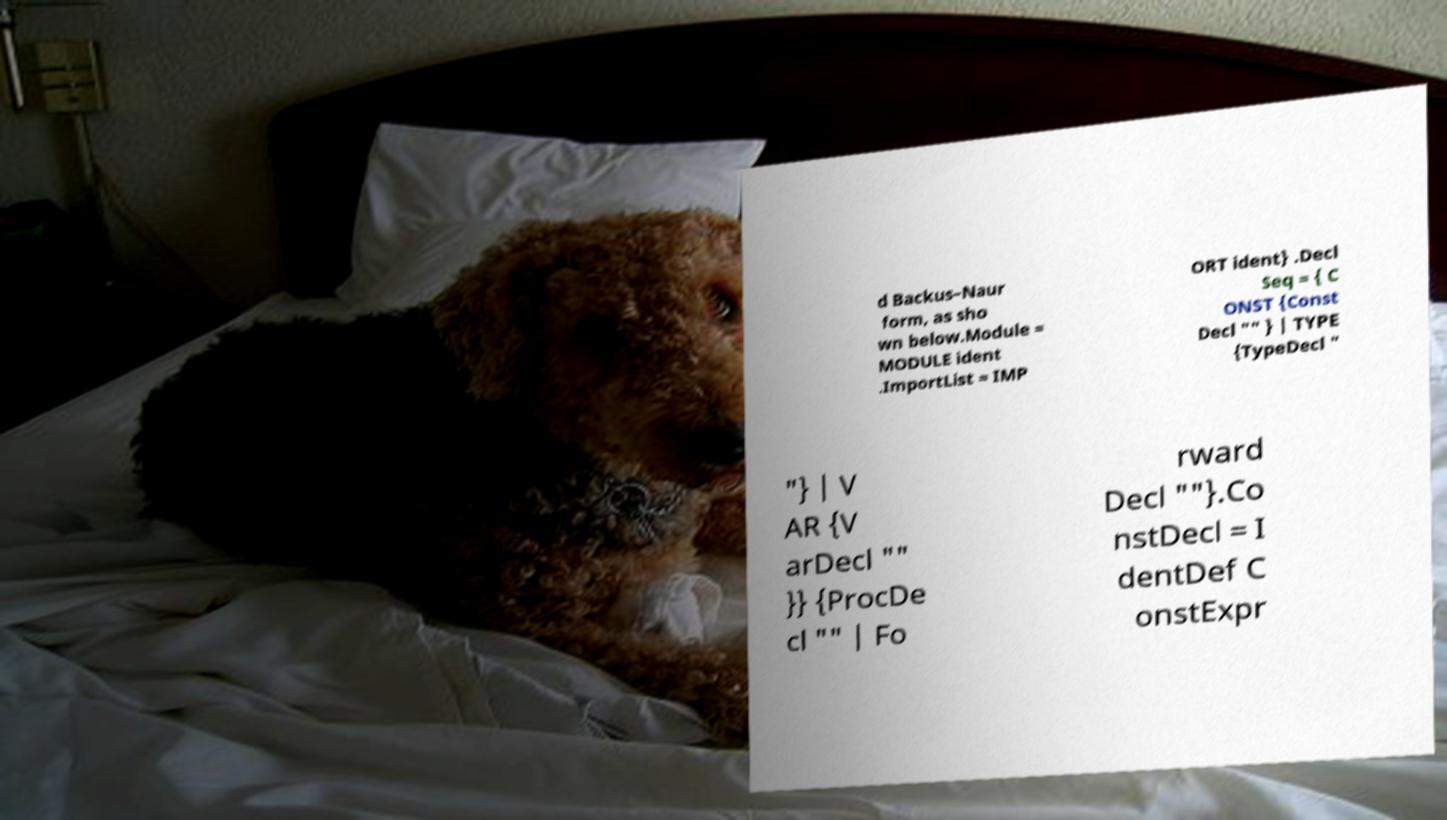I need the written content from this picture converted into text. Can you do that? d Backus–Naur form, as sho wn below.Module = MODULE ident .ImportList = IMP ORT ident} .Decl Seq = { C ONST {Const Decl "" } | TYPE {TypeDecl " "} | V AR {V arDecl "" }} {ProcDe cl "" | Fo rward Decl ""}.Co nstDecl = I dentDef C onstExpr 